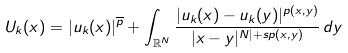<formula> <loc_0><loc_0><loc_500><loc_500>U _ { k } ( x ) = | u _ { k } ( x ) | ^ { { \overline { p } } } + \int _ { \mathbb { R } ^ { N } } \frac { | u _ { k } ( x ) - u _ { k } ( y ) | ^ { p ( x , y ) } } { | x - y | ^ { N | + s p ( x , y ) } } \, d y</formula> 